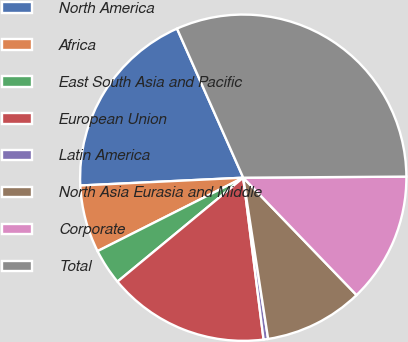Convert chart to OTSL. <chart><loc_0><loc_0><loc_500><loc_500><pie_chart><fcel>North America<fcel>Africa<fcel>East South Asia and Pacific<fcel>European Union<fcel>Latin America<fcel>North Asia Eurasia and Middle<fcel>Corporate<fcel>Total<nl><fcel>19.11%<fcel>6.67%<fcel>3.56%<fcel>16.0%<fcel>0.45%<fcel>9.78%<fcel>12.89%<fcel>31.55%<nl></chart> 